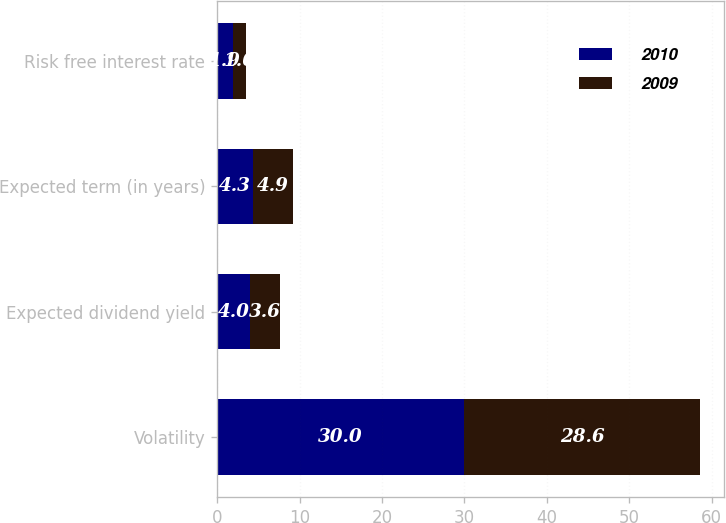Convert chart to OTSL. <chart><loc_0><loc_0><loc_500><loc_500><stacked_bar_chart><ecel><fcel>Volatility<fcel>Expected dividend yield<fcel>Expected term (in years)<fcel>Risk free interest rate<nl><fcel>2010<fcel>30<fcel>4<fcel>4.3<fcel>1.9<nl><fcel>2009<fcel>28.6<fcel>3.6<fcel>4.9<fcel>1.6<nl></chart> 